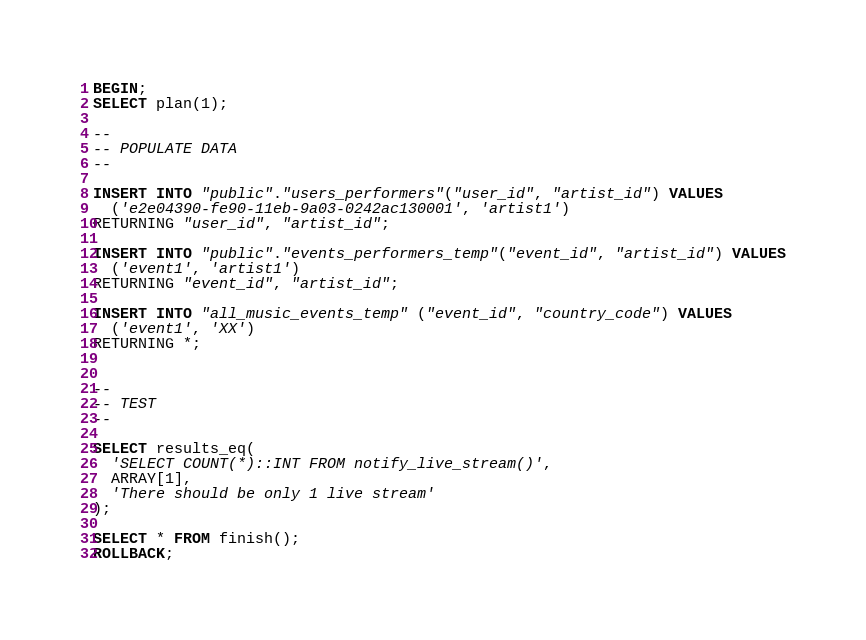Convert code to text. <code><loc_0><loc_0><loc_500><loc_500><_SQL_>BEGIN;
SELECT plan(1);

--
-- POPULATE DATA
--

INSERT INTO "public"."users_performers"("user_id", "artist_id") VALUES
  ('e2e04390-fe90-11eb-9a03-0242ac130001', 'artist1') 
RETURNING "user_id", "artist_id";

INSERT INTO "public"."events_performers_temp"("event_id", "artist_id") VALUES
  ('event1', 'artist1') 
RETURNING "event_id", "artist_id";

INSERT INTO "all_music_events_temp" ("event_id", "country_code") VALUES
  ('event1', 'XX')
RETURNING *;


--
-- TEST
--

SELECT results_eq(
  'SELECT COUNT(*)::INT FROM notify_live_stream()',
  ARRAY[1],
  'There should be only 1 live stream'
);

SELECT * FROM finish();
ROLLBACK;

</code> 